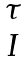<formula> <loc_0><loc_0><loc_500><loc_500>\begin{matrix} \tau \\ I \\ \end{matrix}</formula> 